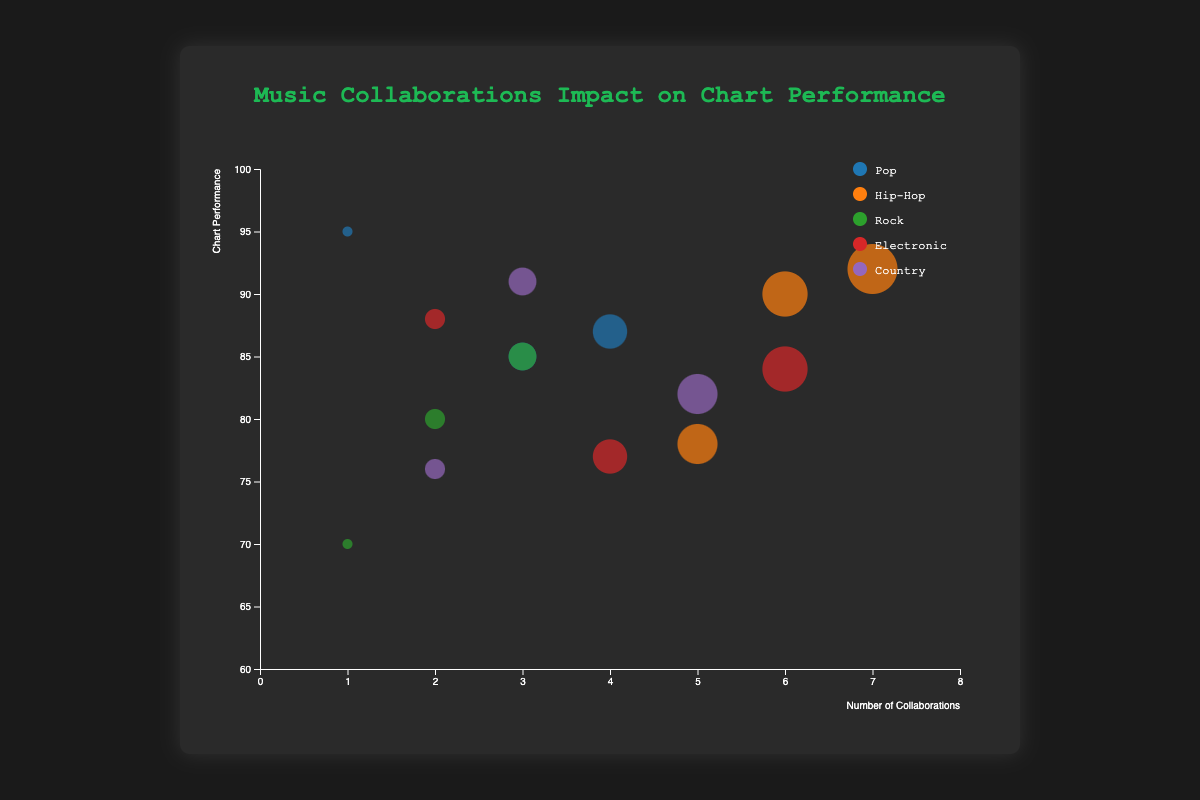What is the genre with the highest overall chart performance? To answer this question, we need to compare the chart performance values for each genre. Looking at the data, the Pop genre has the highest individual chart performance score with Harry Styles' album "Fine Line" scoring 95.
Answer: Pop Which genre has the highest number of collaborations on an album and what is the chart performance of that album? The Hip-Hop genre has the highest number of collaborations on an album, specifically J. Cole's "The Off-Season" with 7 collaborations. This album has a chart performance score of 92.
Answer: Hip-Hop, 92 What is the average chart performance for Rock genres? We need to calculate the average of the chart performance scores for the Rock genre albums. The scores are 80, 70, and 85. Sum these up to get 235, then divide by 3. The average chart performance is approximately 78.33.
Answer: 78.33 Which album has the highest number of collaborations in the Electronic genre? To find this, we look at the collaboration numbers for Electronic genre albums. "Energy" by Disclosure has the highest with 6 collaborations.
Answer: Energy by Disclosure Compare the chart performance of "Chromatica" by Lady Gaga with "Golden Hour" by Kacey Musgraves. Which one performed better? The chart performance for "Chromatica" by Lady Gaga is 87, whereas for "Golden Hour" by Kacey Musgraves, it is 91. Thus, "Golden Hour" performed better.
Answer: Golden Hour In which genre does an album with a higher number of collaborations not necessarily lead to better chart performance? We need to find examples where the number of collaborations does not correlate with higher chart performance. In the Hip-Hop genre, "ASTROWORLD" by Travis Scott has 6 collaborations with a performance of 90, whereas "The Off-Season" by J. Cole has 7 collaborations with a performance of 92, and "Kirk" by DaBaby has 5 collaborations with a performance of 78. This indicates that more collaborations do not always mean better chart performance.
Answer: Hip-Hop What is the least number of collaborations on an album across all genres and what is its chart performance? We need to find the album with the fewest collaborations in the dataset, which is "Fine Line" by Harry Styles with 1 collaboration. Its chart performance is 95.
Answer: 1, 95 Is there a correlation between the number of collaborations and chart performance in the Pop genre? To answer, we observe the Pop genre data. "Future Nostalgia" has 3 collaborations (performance 85), "Fine Line" has 1 collaboration (performance 95), and "Chromatica" has 4 collaborations (performance 87). There is no clear correlation since fewer collaborations resulted in both higher and lower performances.
Answer: No Which genre has the most varied range of chart performances? To determine this, we need to find the difference between the highest and lowest chart performance within each genre. For example, Hip-Hop ranges from 78 to 92, Rock from 70 to 85, and so on. Hip-Hop has the widest range with a spread of 14 (92 - 78).
Answer: Hip-Hop 